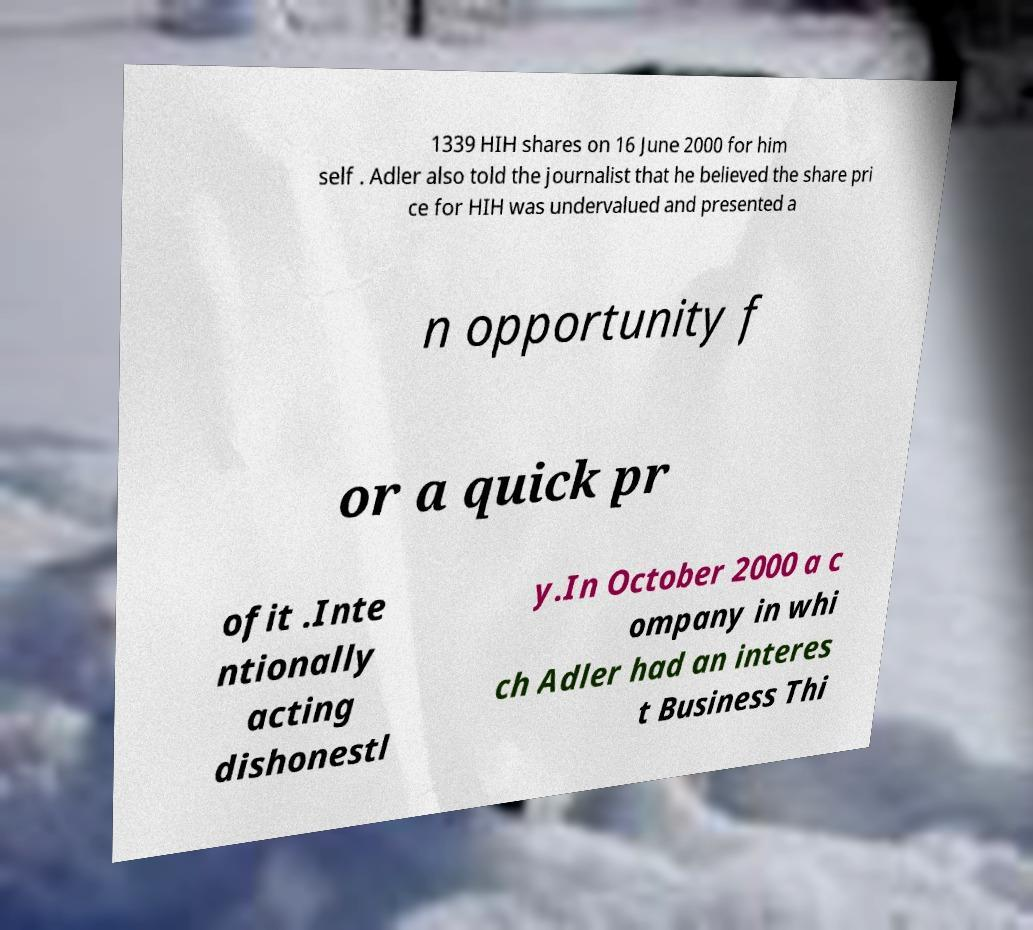Could you assist in decoding the text presented in this image and type it out clearly? 1339 HIH shares on 16 June 2000 for him self . Adler also told the journalist that he believed the share pri ce for HIH was undervalued and presented a n opportunity f or a quick pr ofit .Inte ntionally acting dishonestl y.In October 2000 a c ompany in whi ch Adler had an interes t Business Thi 